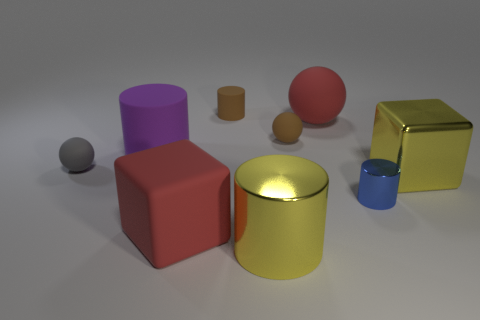Can you tell me how many objects are there in total and what colors they have? In the image, there are six objects in total, each with a distinct color. Starting from the smallest to the largest, we have a tiny gray sphere, a small orange cylinder, a medium-sized red cube, a large purple cylinder, a shiny golden cube, and a vibrant blue cylinder. 